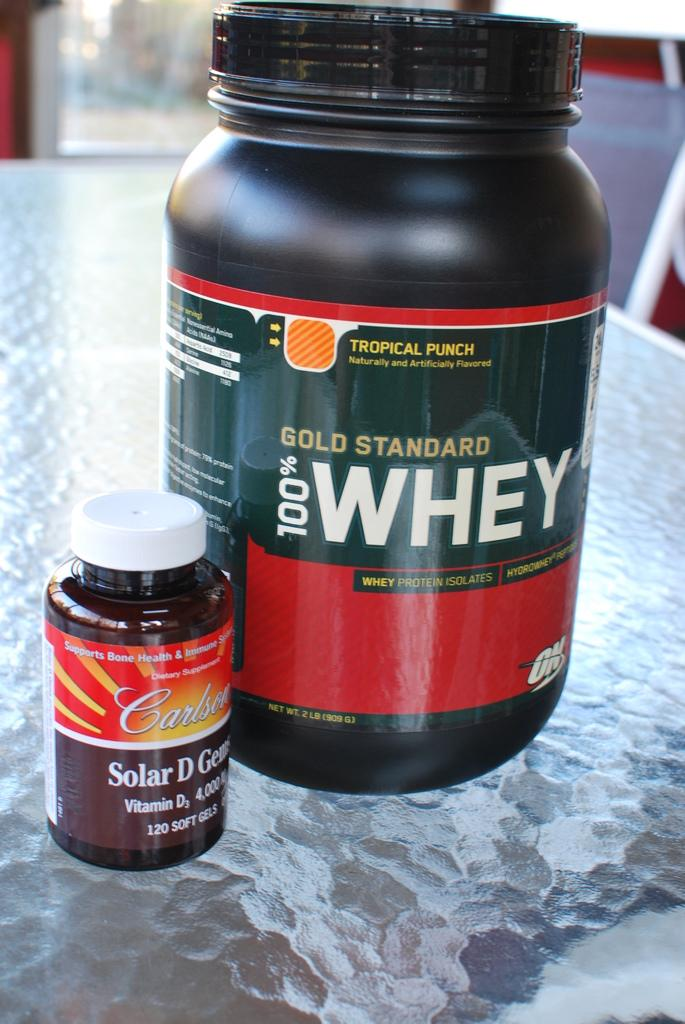<image>
Relay a brief, clear account of the picture shown. A Bold Standard 100% whey bottle sits next to a small vitamin bottle. 